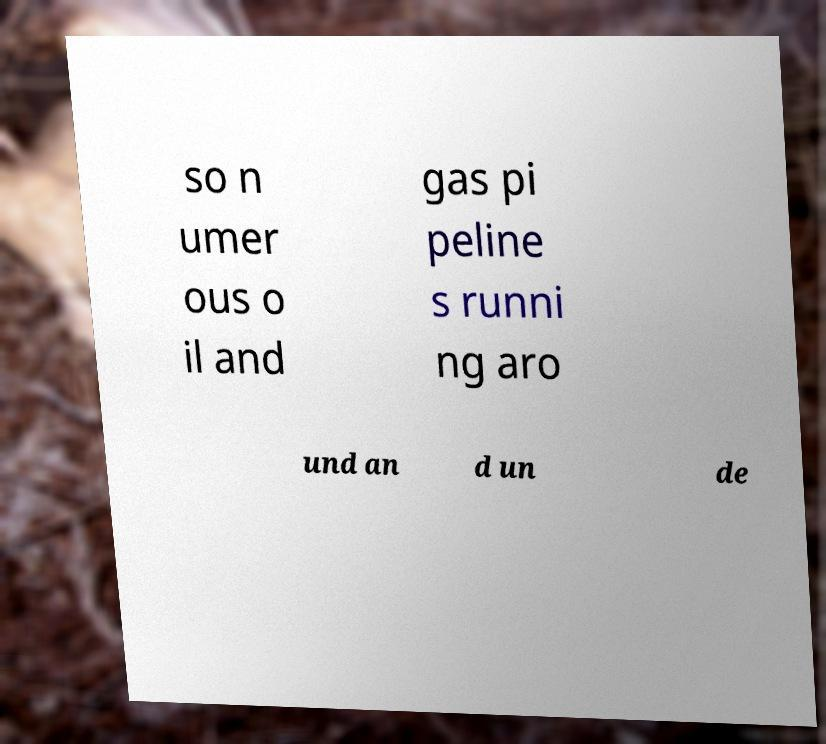Could you assist in decoding the text presented in this image and type it out clearly? so n umer ous o il and gas pi peline s runni ng aro und an d un de 